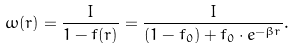<formula> <loc_0><loc_0><loc_500><loc_500>\omega ( r ) = \frac { I } { 1 - f ( r ) } = \frac { I } { ( 1 - f _ { 0 } ) + f _ { 0 } \cdot e ^ { - \beta r } } .</formula> 